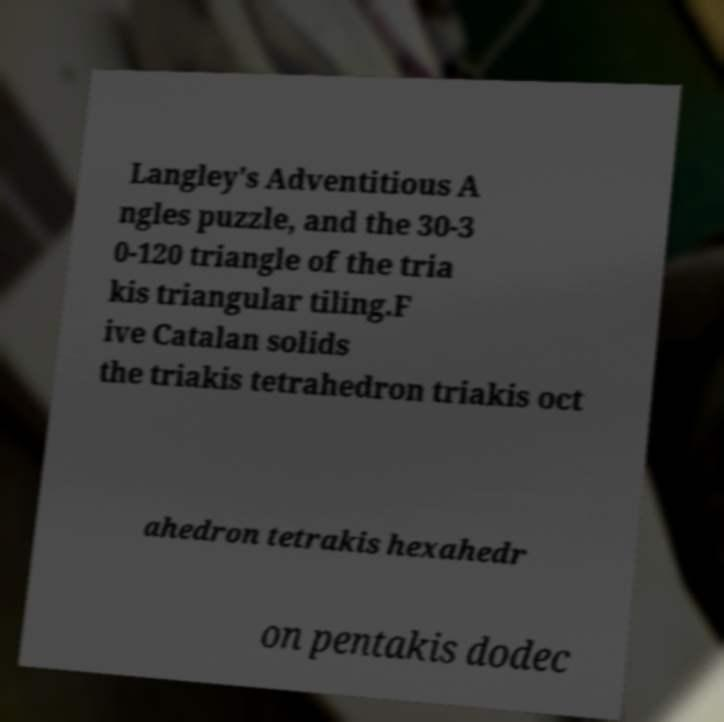For documentation purposes, I need the text within this image transcribed. Could you provide that? Langley's Adventitious A ngles puzzle, and the 30-3 0-120 triangle of the tria kis triangular tiling.F ive Catalan solids the triakis tetrahedron triakis oct ahedron tetrakis hexahedr on pentakis dodec 